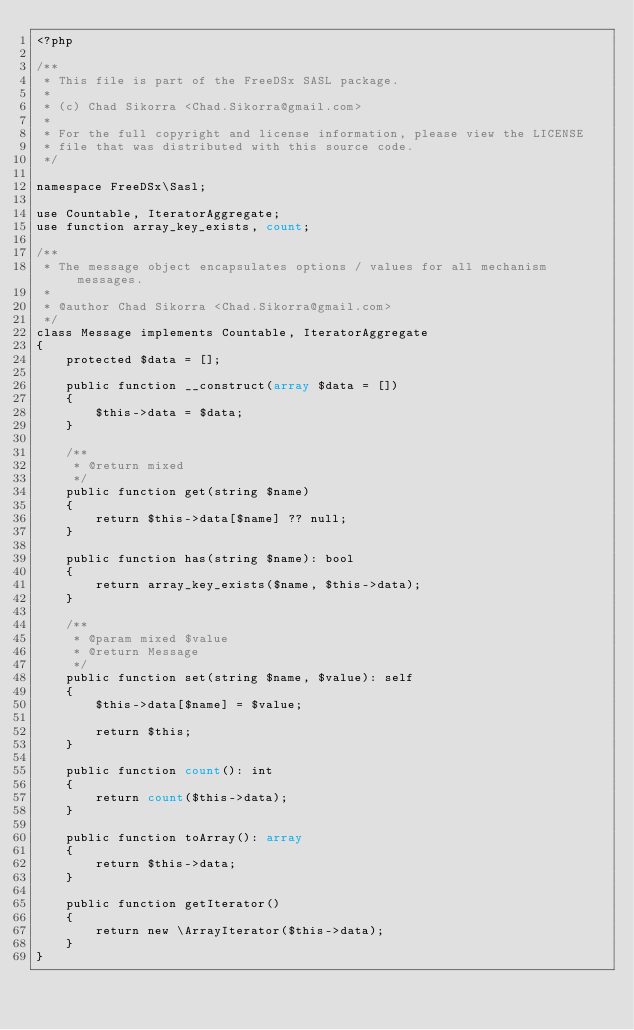Convert code to text. <code><loc_0><loc_0><loc_500><loc_500><_PHP_><?php

/**
 * This file is part of the FreeDSx SASL package.
 *
 * (c) Chad Sikorra <Chad.Sikorra@gmail.com>
 *
 * For the full copyright and license information, please view the LICENSE
 * file that was distributed with this source code.
 */

namespace FreeDSx\Sasl;

use Countable, IteratorAggregate;
use function array_key_exists, count;

/**
 * The message object encapsulates options / values for all mechanism messages.
 *
 * @author Chad Sikorra <Chad.Sikorra@gmail.com>
 */
class Message implements Countable, IteratorAggregate
{
    protected $data = [];

    public function __construct(array $data = [])
    {
        $this->data = $data;
    }

    /**
     * @return mixed
     */
    public function get(string $name)
    {
        return $this->data[$name] ?? null;
    }

    public function has(string $name): bool
    {
        return array_key_exists($name, $this->data);
    }

    /**
     * @param mixed $value
     * @return Message
     */
    public function set(string $name, $value): self
    {
        $this->data[$name] = $value;

        return $this;
    }

    public function count(): int
    {
        return count($this->data);
    }

    public function toArray(): array
    {
        return $this->data;
    }

    public function getIterator()
    {
        return new \ArrayIterator($this->data);
    }
}
</code> 